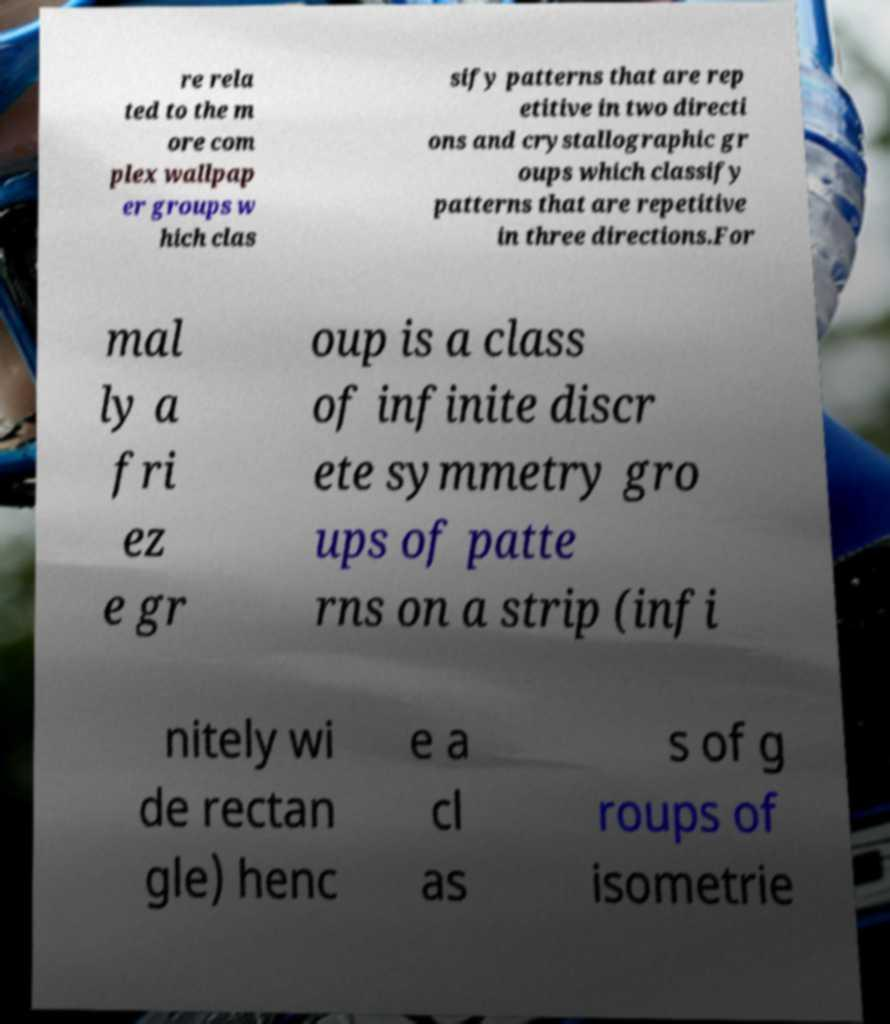For documentation purposes, I need the text within this image transcribed. Could you provide that? re rela ted to the m ore com plex wallpap er groups w hich clas sify patterns that are rep etitive in two directi ons and crystallographic gr oups which classify patterns that are repetitive in three directions.For mal ly a fri ez e gr oup is a class of infinite discr ete symmetry gro ups of patte rns on a strip (infi nitely wi de rectan gle) henc e a cl as s of g roups of isometrie 